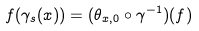Convert formula to latex. <formula><loc_0><loc_0><loc_500><loc_500>f ( \gamma _ { s } ( x ) ) = ( \theta _ { x , 0 } \circ \gamma ^ { - 1 } ) ( f )</formula> 